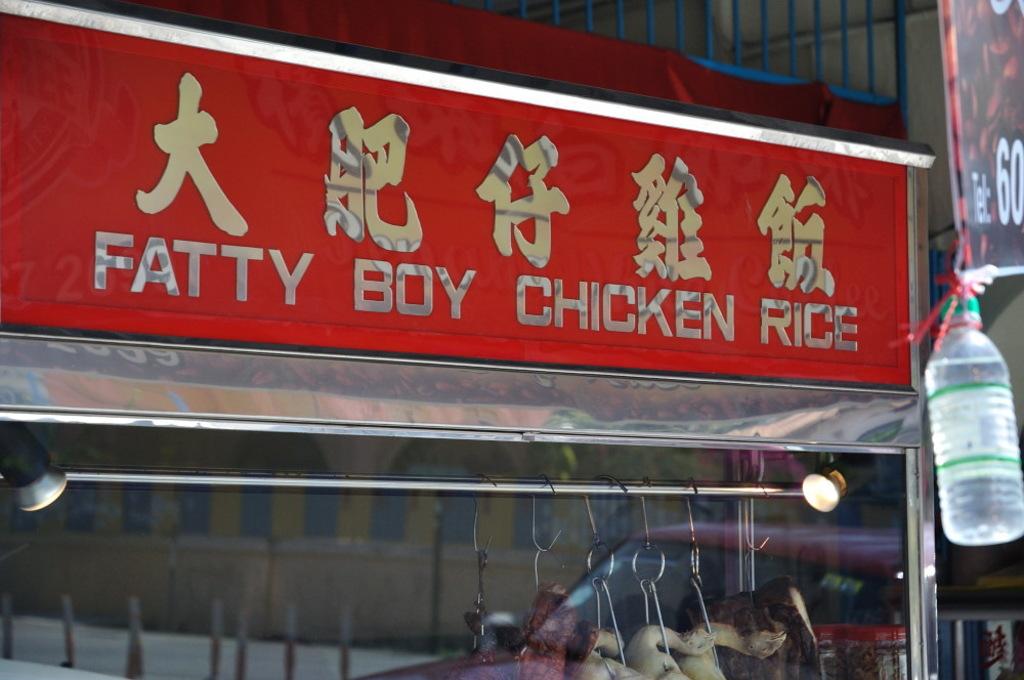What is the name of this food cart?
Offer a very short reply. Fatty boy chicken rice. 